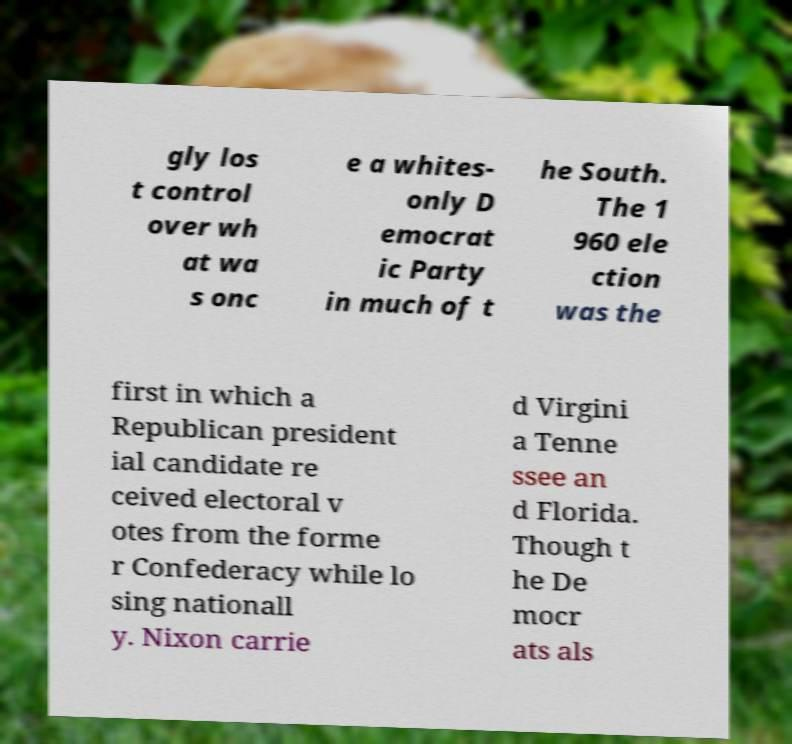Please read and relay the text visible in this image. What does it say? gly los t control over wh at wa s onc e a whites- only D emocrat ic Party in much of t he South. The 1 960 ele ction was the first in which a Republican president ial candidate re ceived electoral v otes from the forme r Confederacy while lo sing nationall y. Nixon carrie d Virgini a Tenne ssee an d Florida. Though t he De mocr ats als 